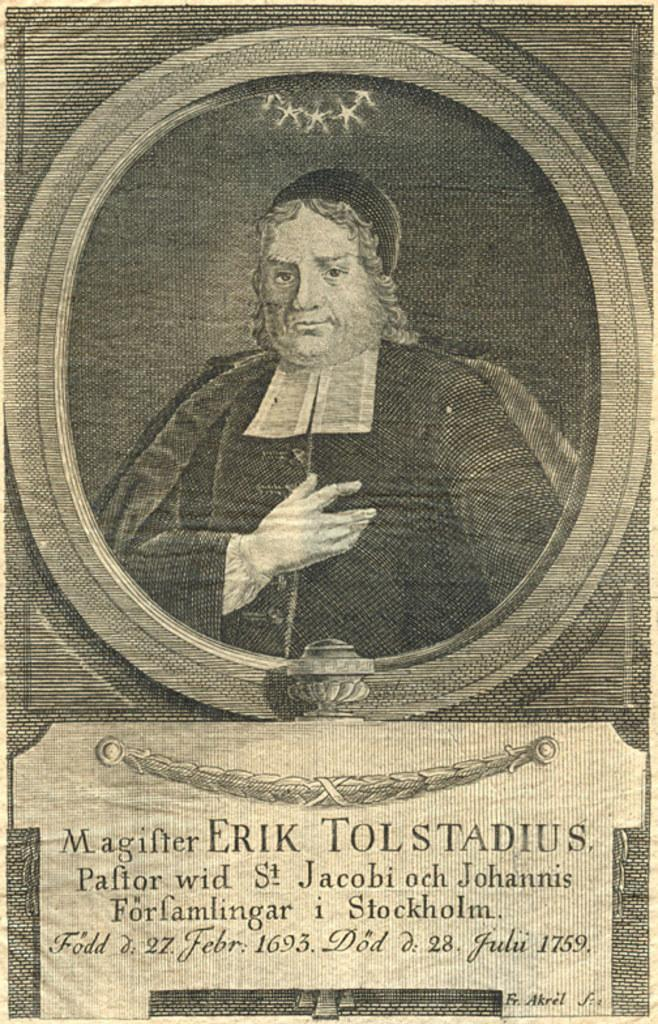What is the main subject of the image? There is a person in the image. What is written at the bottom of the image? There is text at the bottom of the image. What type of glass is the person holding in the image? There is no glass present in the image. Is the person wearing a coat in the image? No information about the person's clothing is provided in the facts. Can you see the sea in the background of the image? There is no mention of a sea or any background in the provided facts. 